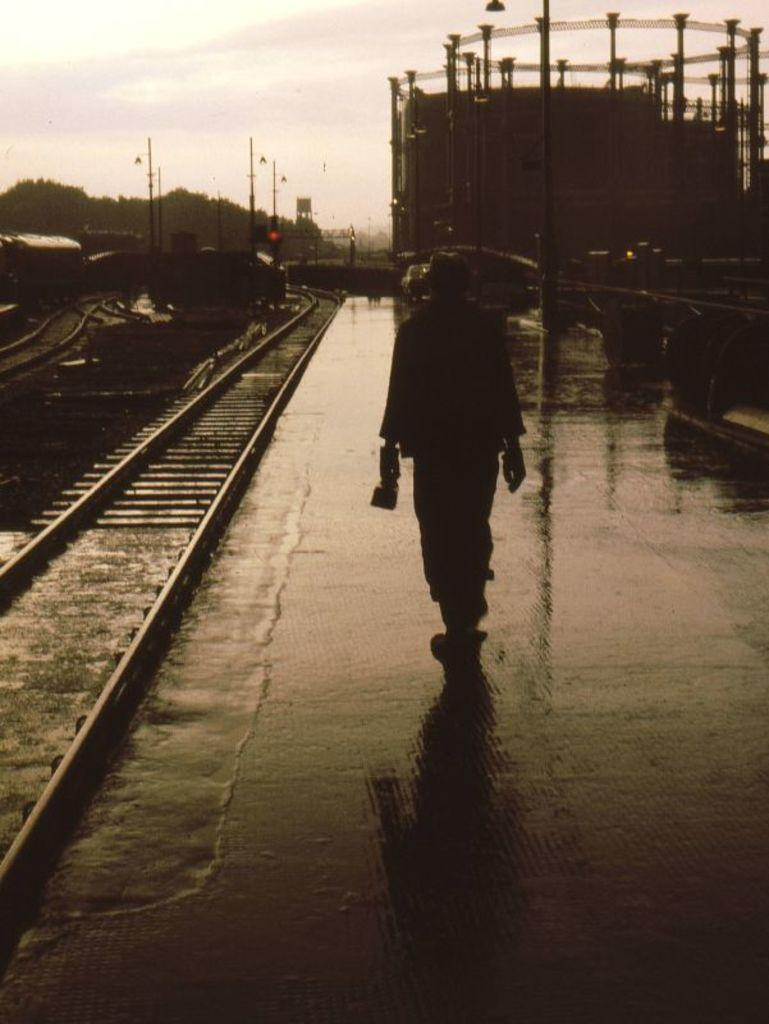What is the man in the image doing? The man is walking in the image. Where is the man walking? The man is walking on a platform. What can be seen in the background of the image? Poles and signals are visible in the image. What might be located near the tracks in the bottom left corner of the image? The tracks in the bottom left corner of the image suggest that a train or railway system might be nearby. What memory does the man have of his trip to the judge's office in the image? There is no mention of a trip to the judge's office or any memory in the image. The image only shows a man walking on a platform with poles and signals visible in the background. 